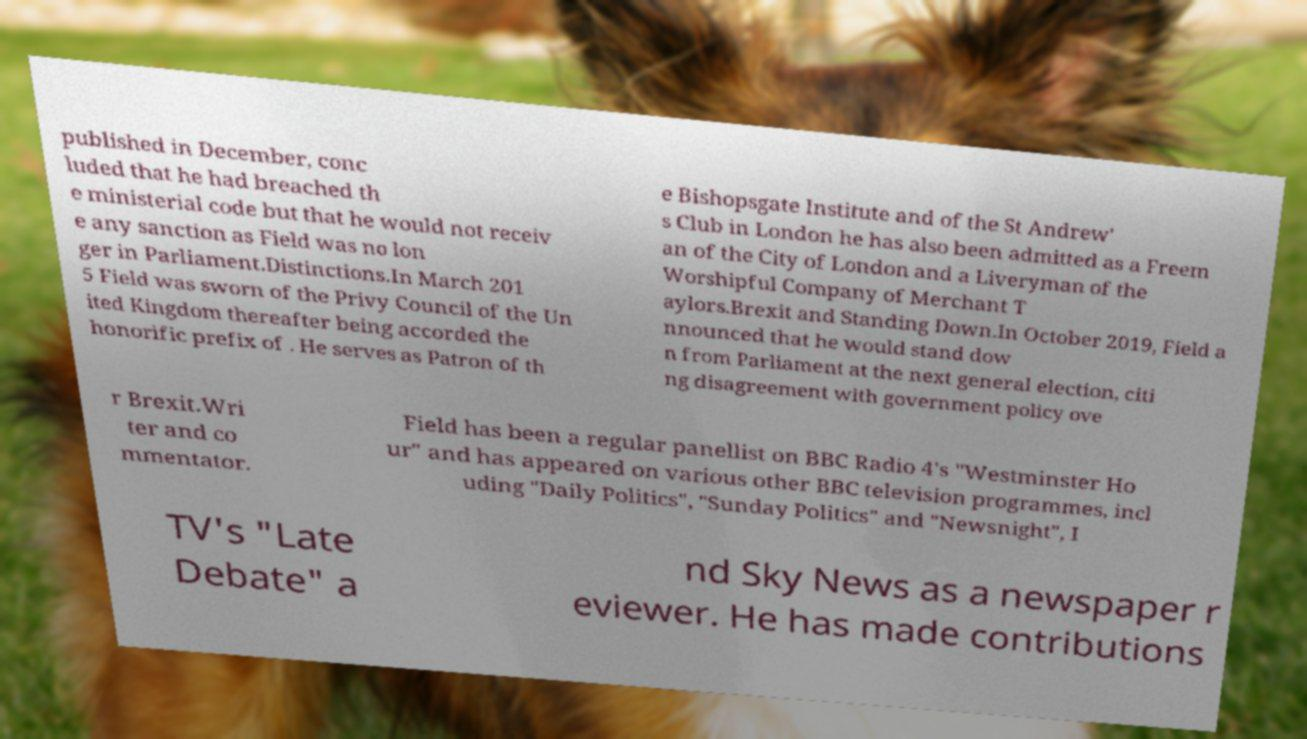For documentation purposes, I need the text within this image transcribed. Could you provide that? published in December, conc luded that he had breached th e ministerial code but that he would not receiv e any sanction as Field was no lon ger in Parliament.Distinctions.In March 201 5 Field was sworn of the Privy Council of the Un ited Kingdom thereafter being accorded the honorific prefix of . He serves as Patron of th e Bishopsgate Institute and of the St Andrew' s Club in London he has also been admitted as a Freem an of the City of London and a Liveryman of the Worshipful Company of Merchant T aylors.Brexit and Standing Down.In October 2019, Field a nnounced that he would stand dow n from Parliament at the next general election, citi ng disagreement with government policy ove r Brexit.Wri ter and co mmentator. Field has been a regular panellist on BBC Radio 4's "Westminster Ho ur" and has appeared on various other BBC television programmes, incl uding "Daily Politics", "Sunday Politics" and "Newsnight", I TV's "Late Debate" a nd Sky News as a newspaper r eviewer. He has made contributions 